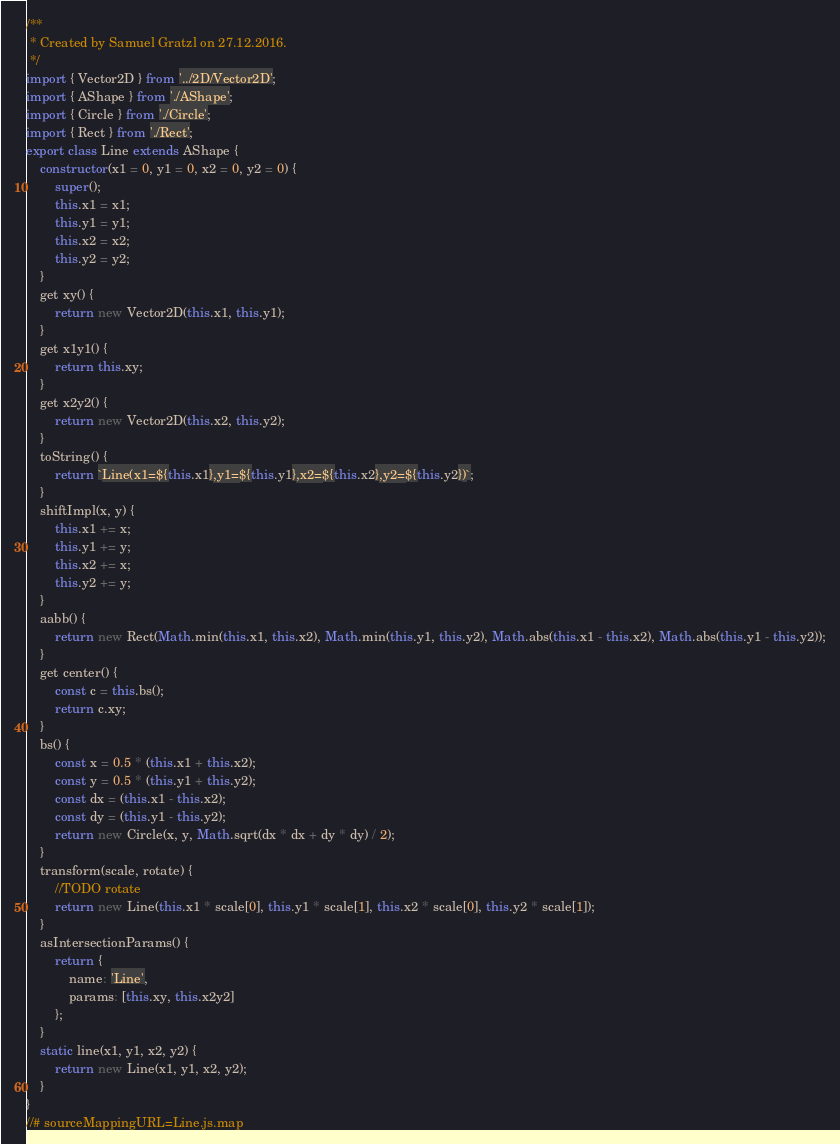Convert code to text. <code><loc_0><loc_0><loc_500><loc_500><_JavaScript_>/**
 * Created by Samuel Gratzl on 27.12.2016.
 */
import { Vector2D } from '../2D/Vector2D';
import { AShape } from './AShape';
import { Circle } from './Circle';
import { Rect } from './Rect';
export class Line extends AShape {
    constructor(x1 = 0, y1 = 0, x2 = 0, y2 = 0) {
        super();
        this.x1 = x1;
        this.y1 = y1;
        this.x2 = x2;
        this.y2 = y2;
    }
    get xy() {
        return new Vector2D(this.x1, this.y1);
    }
    get x1y1() {
        return this.xy;
    }
    get x2y2() {
        return new Vector2D(this.x2, this.y2);
    }
    toString() {
        return `Line(x1=${this.x1},y1=${this.y1},x2=${this.x2},y2=${this.y2})`;
    }
    shiftImpl(x, y) {
        this.x1 += x;
        this.y1 += y;
        this.x2 += x;
        this.y2 += y;
    }
    aabb() {
        return new Rect(Math.min(this.x1, this.x2), Math.min(this.y1, this.y2), Math.abs(this.x1 - this.x2), Math.abs(this.y1 - this.y2));
    }
    get center() {
        const c = this.bs();
        return c.xy;
    }
    bs() {
        const x = 0.5 * (this.x1 + this.x2);
        const y = 0.5 * (this.y1 + this.y2);
        const dx = (this.x1 - this.x2);
        const dy = (this.y1 - this.y2);
        return new Circle(x, y, Math.sqrt(dx * dx + dy * dy) / 2);
    }
    transform(scale, rotate) {
        //TODO rotate
        return new Line(this.x1 * scale[0], this.y1 * scale[1], this.x2 * scale[0], this.y2 * scale[1]);
    }
    asIntersectionParams() {
        return {
            name: 'Line',
            params: [this.xy, this.x2y2]
        };
    }
    static line(x1, y1, x2, y2) {
        return new Line(x1, y1, x2, y2);
    }
}
//# sourceMappingURL=Line.js.map</code> 